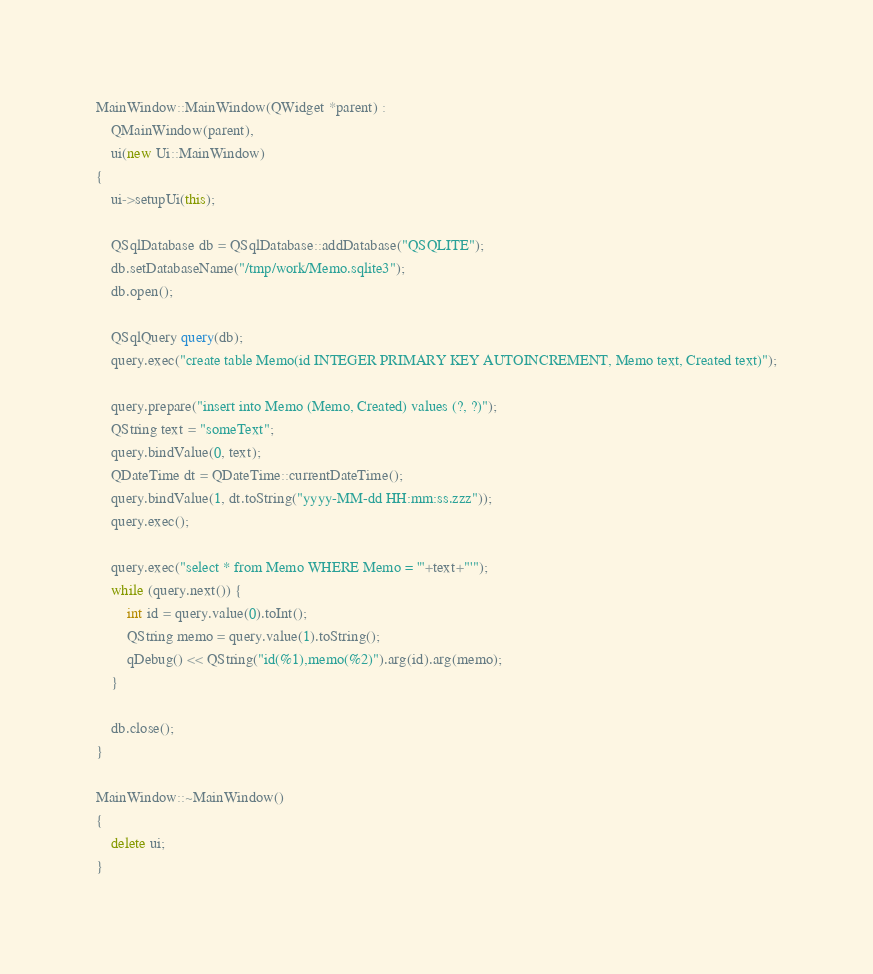Convert code to text. <code><loc_0><loc_0><loc_500><loc_500><_C++_>
MainWindow::MainWindow(QWidget *parent) :
    QMainWindow(parent),
    ui(new Ui::MainWindow)
{
    ui->setupUi(this);

    QSqlDatabase db = QSqlDatabase::addDatabase("QSQLITE");
    db.setDatabaseName("/tmp/work/Memo.sqlite3");
    db.open();

    QSqlQuery query(db);
    query.exec("create table Memo(id INTEGER PRIMARY KEY AUTOINCREMENT, Memo text, Created text)");

    query.prepare("insert into Memo (Memo, Created) values (?, ?)");
    QString text = "someText";
    query.bindValue(0, text);
    QDateTime dt = QDateTime::currentDateTime();
    query.bindValue(1, dt.toString("yyyy-MM-dd HH:mm:ss.zzz"));
    query.exec();

    query.exec("select * from Memo WHERE Memo = '"+text+"'");
    while (query.next()) {
        int id = query.value(0).toInt();
        QString memo = query.value(1).toString();
        qDebug() << QString("id(%1),memo(%2)").arg(id).arg(memo);
    }

    db.close();
}

MainWindow::~MainWindow()
{
    delete ui;
}
</code> 